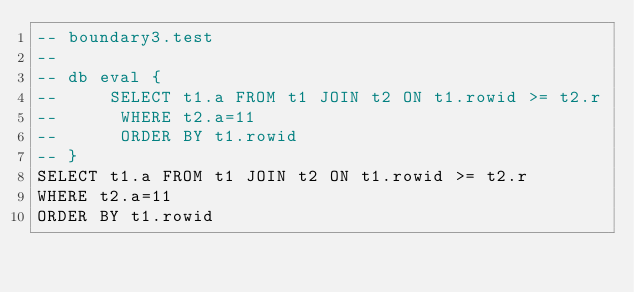Convert code to text. <code><loc_0><loc_0><loc_500><loc_500><_SQL_>-- boundary3.test
-- 
-- db eval {
--     SELECT t1.a FROM t1 JOIN t2 ON t1.rowid >= t2.r
--      WHERE t2.a=11
--      ORDER BY t1.rowid
-- }
SELECT t1.a FROM t1 JOIN t2 ON t1.rowid >= t2.r
WHERE t2.a=11
ORDER BY t1.rowid</code> 